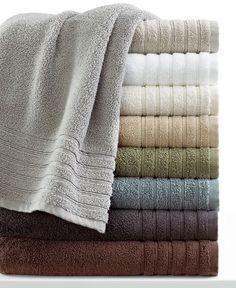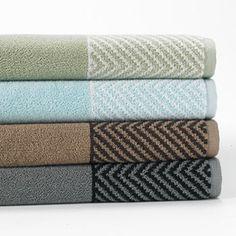The first image is the image on the left, the second image is the image on the right. Examine the images to the left and right. Is the description "The corners are pulled up on two towels." accurate? Answer yes or no. No. The first image is the image on the left, the second image is the image on the right. For the images displayed, is the sentence "There are two stacks of towels in the image on the right." factually correct? Answer yes or no. No. 